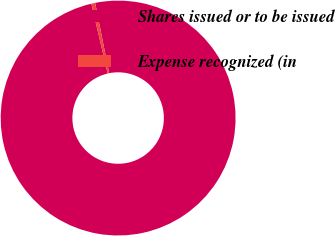Convert chart. <chart><loc_0><loc_0><loc_500><loc_500><pie_chart><fcel>Shares issued or to be issued<fcel>Expense recognized (in<nl><fcel>99.48%<fcel>0.52%<nl></chart> 